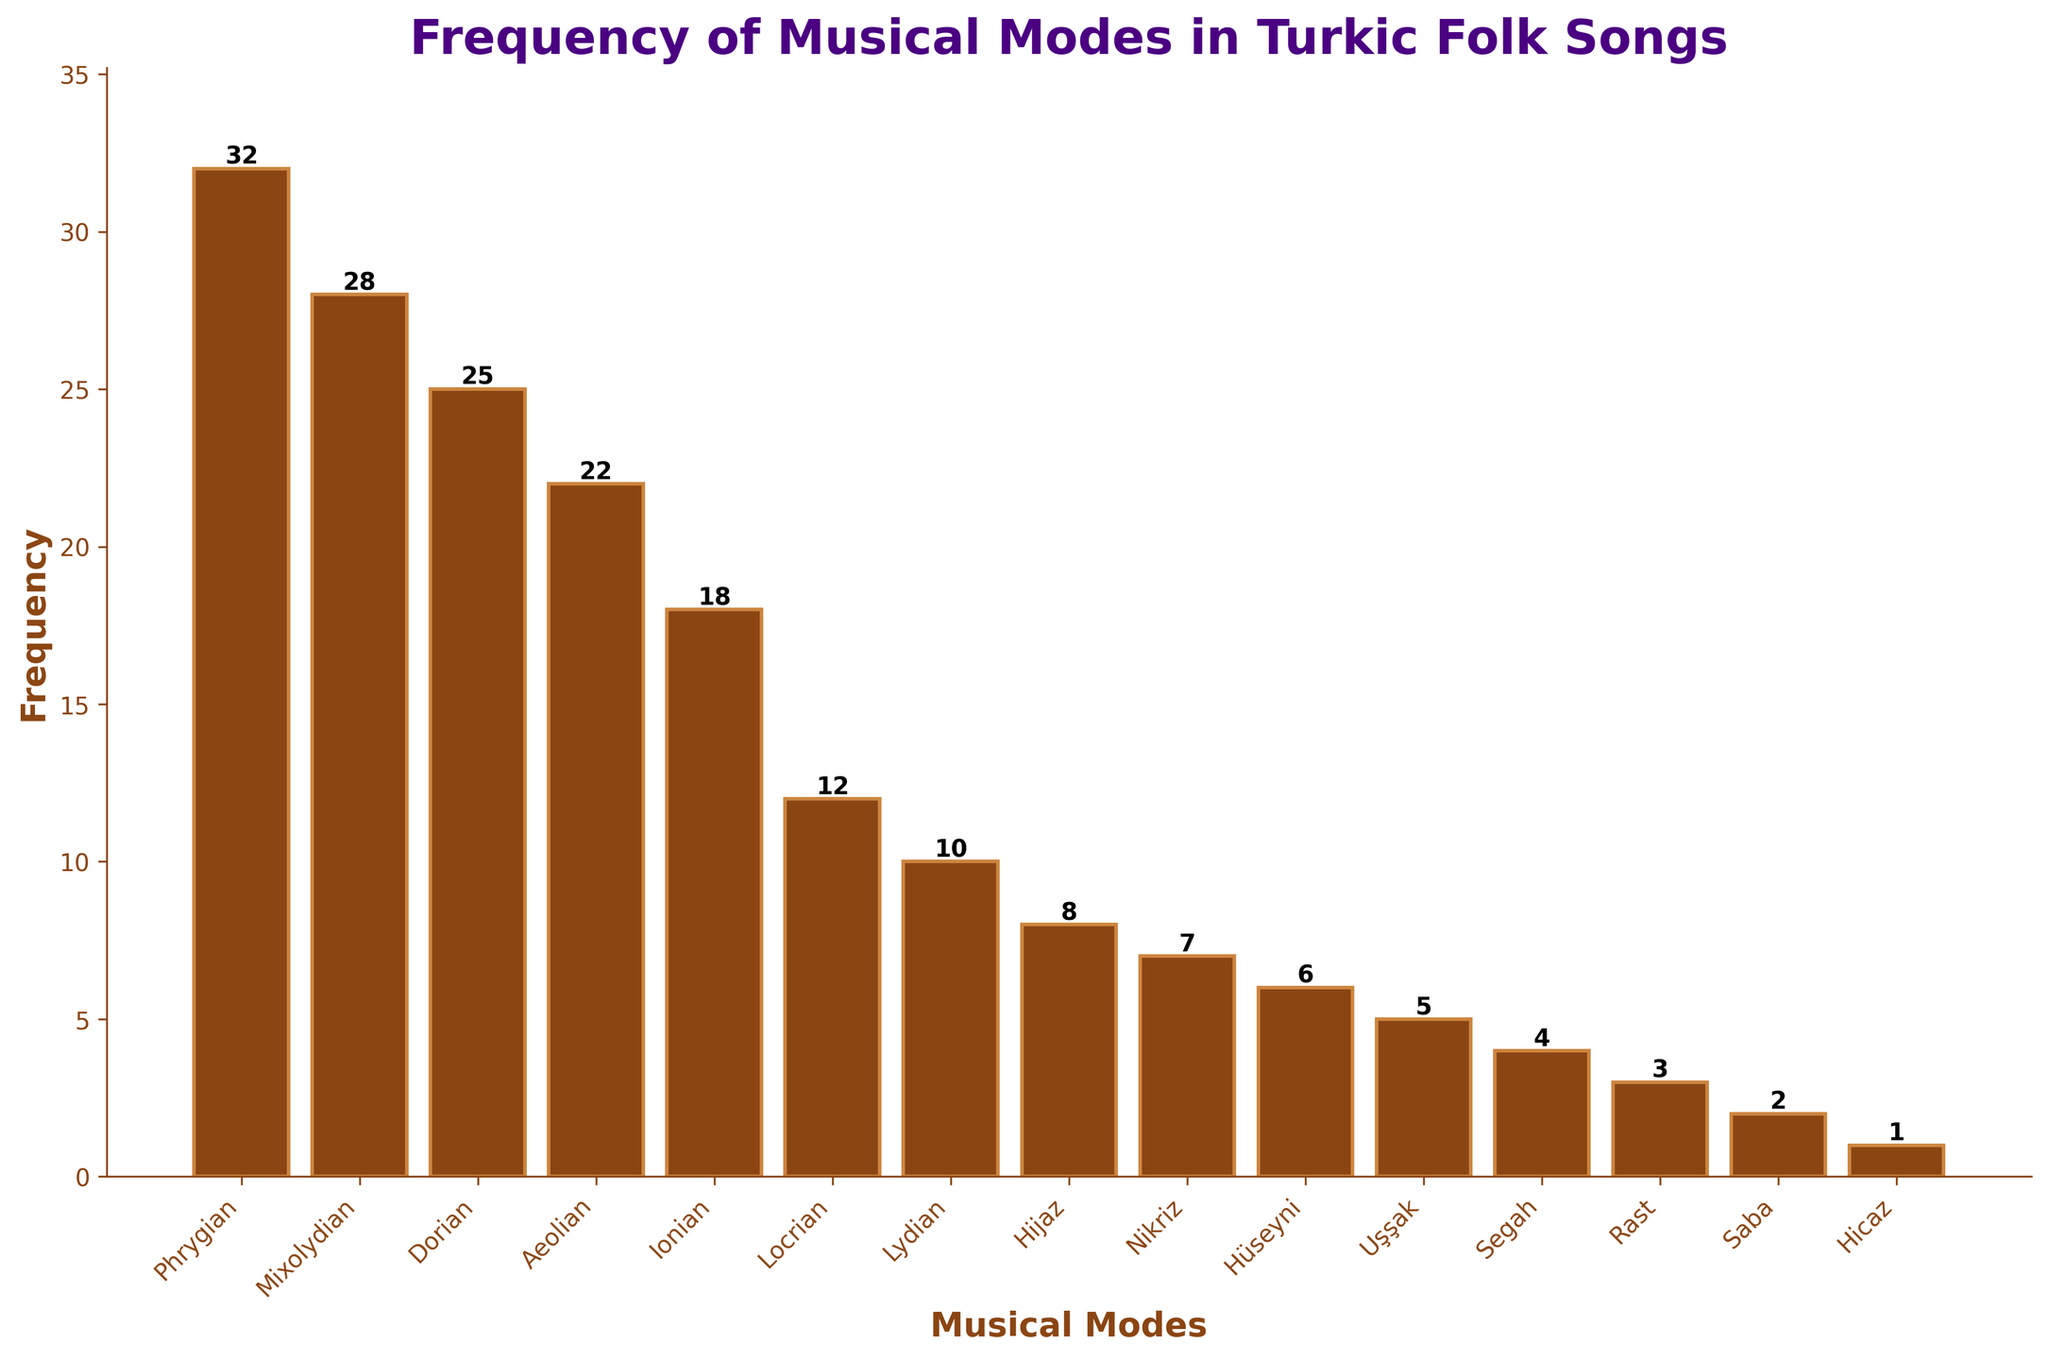Which musical mode has the highest frequency? Upon examining the chart, the bar corresponding to the "Phrygian" mode is the tallest, indicating that it has the highest frequency of occurrence in Turkic folk songs.
Answer: Phrygian How many musical modes have a frequency greater than 20? By visually comparing the heights of the bars, we can see that "Phrygian," "Mixolydian," and "Dorian" modes have frequencies greater than 20. There are three such modes.
Answer: 3 What is the total frequency of the "Hijaz," "Nikriz," and "Hüseyni" modes combined? The frequencies of "Hijaz," "Nikriz," and "Hüseyni" are 8, 7, and 6 respectively. Summing these values, 8 + 7 + 6, gives a total frequency of 21.
Answer: 21 Which mode has a frequency exactly half of the "Phrygian" mode? The "Phrygian" mode has a frequency of 32. Half of 32 is 16. By examining the chart, no mode has a frequency of 16.
Answer: None What is the difference in frequency between the "Ionian" and "Locrian" modes? The frequencies of the "Ionian" and "Locrian" modes are 18 and 12, respectively. The difference between these values, 18 - 12, is 6.
Answer: 6 How many modes have a frequency less than or equal to 10? By counting the bars with frequencies less than or equal to 10, we identify "Locrian," "Lydian," "Hijaz," "Nikriz," "Hüseyni," "Uşşak," "Segah," "Rast," "Saba," and "Hicaz." There are ten such modes.
Answer: 10 Which has a higher frequency, the sum of "Saba" and "Hicaz" or the "Hüseyni" mode? The frequencies of "Saba" and "Hicaz" are 2 and 1, respectively. Their sum is 2 + 1 = 3. The frequency of "Hüseyni" is 6, which is higher than 3.
Answer: Hüseyni What is the average frequency of the top three modes? The top three modes are "Phrygian" (32), "Mixolydian" (28), and "Dorian" (25). Summing these values, 32 + 28 + 25, gives 85. The average, 85/3, is approximately 28.33.
Answer: 28.33 Which modes have frequencies below the average frequency of all modes? The total frequency of all modes can be summed and divided by the number of modes. Total frequency = 32 + 28 + 25 + 22 + 18 + 12 + 10 + 8 + 7 + 6 + 5 + 4 + 3 + 2 + 1 = 183. Average frequency = 183/15 = 12.2. Modes below 12.2 are "Locrian," "Lydian," "Hijaz," "Nikriz," "Hüseyni," "Uşşak," "Segah," "Rast," "Saba," and "Hicaz." Hence, there are ten such modes.
Answer: 10 What is the median frequency among all the modes? After ordering the frequencies, we get: 1, 2, 3, 4, 5, 6, 7, 8, 10, 12, 18, 22, 25, 28, 32. The median is the middle value. For 15 values, the median is the 8th value, which is 8.
Answer: 8 